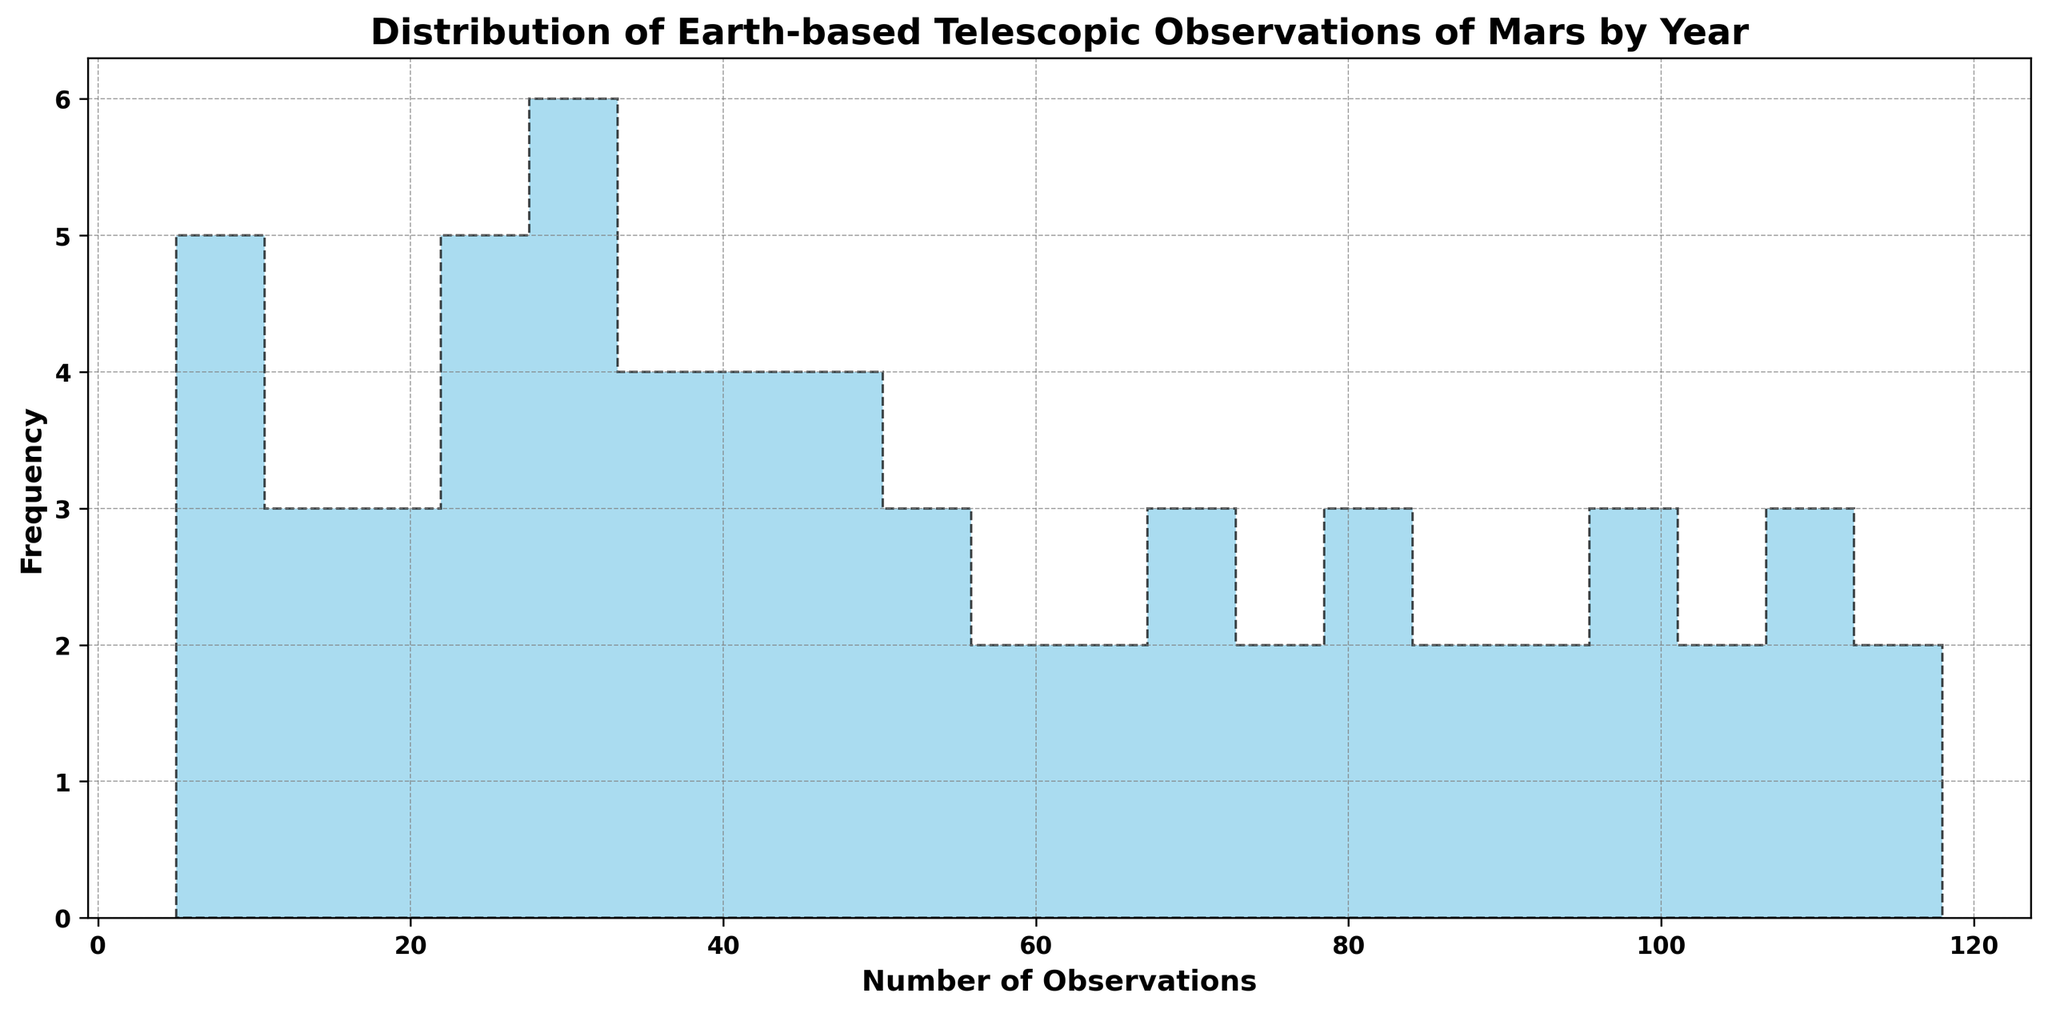Which years had the lowest number of observations? The lowest number of observations correspond to the smallest bin on the histogram. Observations in the 5-10 range (1960-1963) show the lowest number of observations.
Answer: 1960-1963 Compare the number of observations in the bins with the highest and the lowest frequency. What do you notice? The bins representing the lowest number of observations have fewer frequencies, indicating fewer years with lower observations. Conversely, bins with 85-115 observations show higher frequencies, indicating more years with high observational counts.
Answer: Higher frequencies in higher observation bins What is the range of observations shown in the histogram? The range of observations is given from the lowest to the highest value. Observations span from 5 to 118.
Answer: 5 to 118 Which bins contain the most frequent number of observations? The tallest bins represent the most frequently occurring number of observations. The bins with observations around 85-115 appear tallest.
Answer: 85-115 Describe the trend in observations over the years as depicted by the histogram. The histogram shows a positive trend where the frequency of higher numbers of observations (e.g., 85-115) has increased over the years, indicating more observations being made as time progresses.
Answer: Increasing trend Is the distribution of observations symmetric, skewed to the left, or skewed to the right? By observing the shape of the histogram, if the bars lean towards the right, it indicates a left skew. If they lean left, it indicates a right skew. The histogram leans to the left due to the higher frequency of observations in later years.
Answer: Skewed to the left How does the data from 1970-1980 compare to that from 1990-2000? To compare, observe the bins corresponding to the number of observations around those years. 1970-1980 contains more observations in the lower bins, while 1990-2000 shows higher observations, indicative of an increased number of observations over time.
Answer: 1990-2000 has more What's the median number of observations in the histogram? The median is the middle value of the dataset when ordered. By locating the bins, the median falls around the midpoint bins. Given the spread and skew, it's around 70 observations.
Answer: ~70 Which part of the histogram contains outliers, if any? Outliers are typically outside the majority range. The left end of the histogram that contains the smallest counts (5-10) could be considered outliers compared to higher frequencies.
Answer: 5-10 observations 